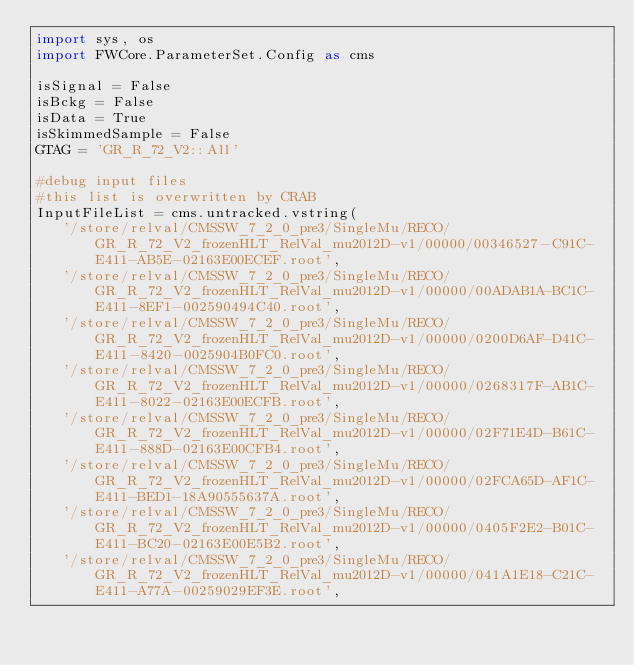<code> <loc_0><loc_0><loc_500><loc_500><_Python_>import sys, os
import FWCore.ParameterSet.Config as cms

isSignal = False
isBckg = False
isData = True
isSkimmedSample = False
GTAG = 'GR_R_72_V2::All'

#debug input files 
#this list is overwritten by CRAB
InputFileList = cms.untracked.vstring(
   '/store/relval/CMSSW_7_2_0_pre3/SingleMu/RECO/GR_R_72_V2_frozenHLT_RelVal_mu2012D-v1/00000/00346527-C91C-E411-AB5E-02163E00ECEF.root',
   '/store/relval/CMSSW_7_2_0_pre3/SingleMu/RECO/GR_R_72_V2_frozenHLT_RelVal_mu2012D-v1/00000/00ADAB1A-BC1C-E411-8EF1-002590494C40.root',
   '/store/relval/CMSSW_7_2_0_pre3/SingleMu/RECO/GR_R_72_V2_frozenHLT_RelVal_mu2012D-v1/00000/0200D6AF-D41C-E411-8420-0025904B0FC0.root',
   '/store/relval/CMSSW_7_2_0_pre3/SingleMu/RECO/GR_R_72_V2_frozenHLT_RelVal_mu2012D-v1/00000/0268317F-AB1C-E411-8022-02163E00ECFB.root',
   '/store/relval/CMSSW_7_2_0_pre3/SingleMu/RECO/GR_R_72_V2_frozenHLT_RelVal_mu2012D-v1/00000/02F71E4D-B61C-E411-888D-02163E00CFB4.root',
   '/store/relval/CMSSW_7_2_0_pre3/SingleMu/RECO/GR_R_72_V2_frozenHLT_RelVal_mu2012D-v1/00000/02FCA65D-AF1C-E411-BED1-18A90555637A.root',
   '/store/relval/CMSSW_7_2_0_pre3/SingleMu/RECO/GR_R_72_V2_frozenHLT_RelVal_mu2012D-v1/00000/0405F2E2-B01C-E411-BC20-02163E00E5B2.root',
   '/store/relval/CMSSW_7_2_0_pre3/SingleMu/RECO/GR_R_72_V2_frozenHLT_RelVal_mu2012D-v1/00000/041A1E18-C21C-E411-A77A-00259029EF3E.root',</code> 